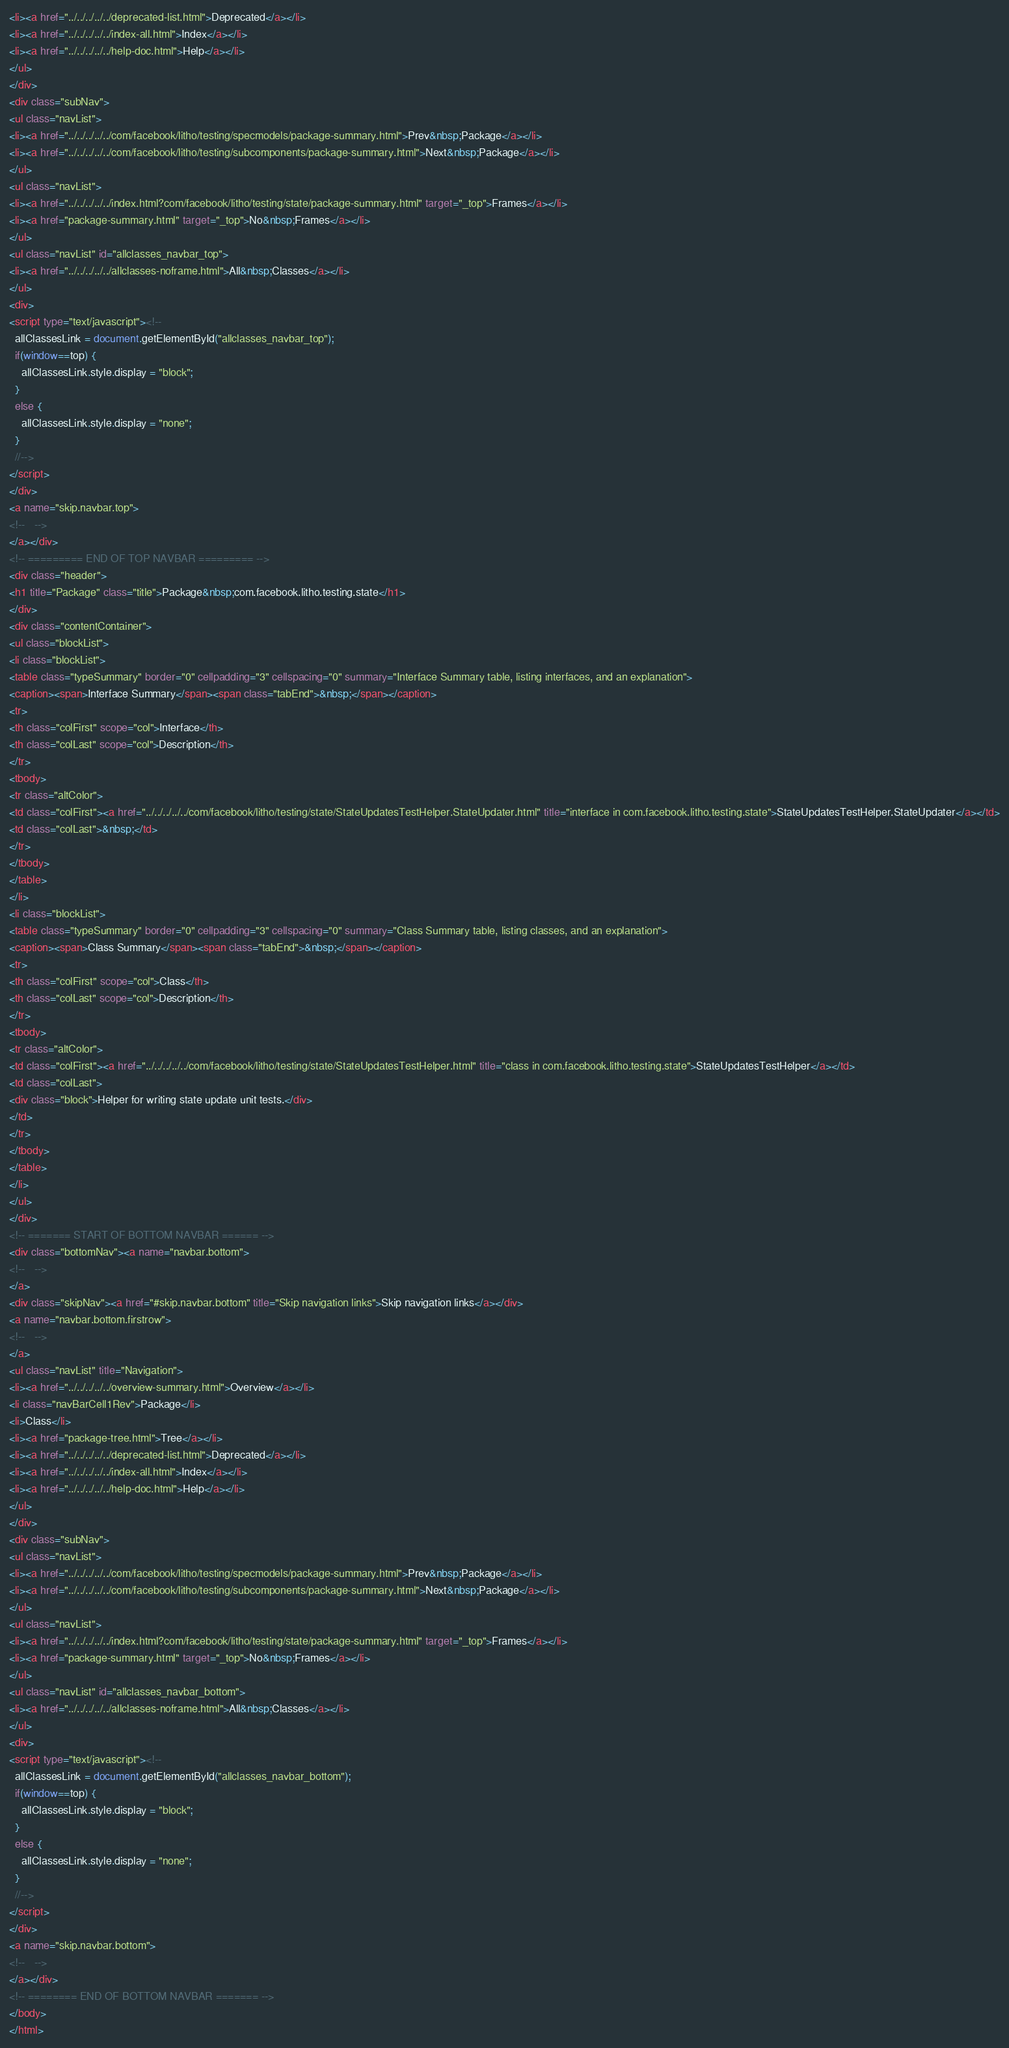Convert code to text. <code><loc_0><loc_0><loc_500><loc_500><_HTML_><li><a href="../../../../../deprecated-list.html">Deprecated</a></li>
<li><a href="../../../../../index-all.html">Index</a></li>
<li><a href="../../../../../help-doc.html">Help</a></li>
</ul>
</div>
<div class="subNav">
<ul class="navList">
<li><a href="../../../../../com/facebook/litho/testing/specmodels/package-summary.html">Prev&nbsp;Package</a></li>
<li><a href="../../../../../com/facebook/litho/testing/subcomponents/package-summary.html">Next&nbsp;Package</a></li>
</ul>
<ul class="navList">
<li><a href="../../../../../index.html?com/facebook/litho/testing/state/package-summary.html" target="_top">Frames</a></li>
<li><a href="package-summary.html" target="_top">No&nbsp;Frames</a></li>
</ul>
<ul class="navList" id="allclasses_navbar_top">
<li><a href="../../../../../allclasses-noframe.html">All&nbsp;Classes</a></li>
</ul>
<div>
<script type="text/javascript"><!--
  allClassesLink = document.getElementById("allclasses_navbar_top");
  if(window==top) {
    allClassesLink.style.display = "block";
  }
  else {
    allClassesLink.style.display = "none";
  }
  //-->
</script>
</div>
<a name="skip.navbar.top">
<!--   -->
</a></div>
<!-- ========= END OF TOP NAVBAR ========= -->
<div class="header">
<h1 title="Package" class="title">Package&nbsp;com.facebook.litho.testing.state</h1>
</div>
<div class="contentContainer">
<ul class="blockList">
<li class="blockList">
<table class="typeSummary" border="0" cellpadding="3" cellspacing="0" summary="Interface Summary table, listing interfaces, and an explanation">
<caption><span>Interface Summary</span><span class="tabEnd">&nbsp;</span></caption>
<tr>
<th class="colFirst" scope="col">Interface</th>
<th class="colLast" scope="col">Description</th>
</tr>
<tbody>
<tr class="altColor">
<td class="colFirst"><a href="../../../../../com/facebook/litho/testing/state/StateUpdatesTestHelper.StateUpdater.html" title="interface in com.facebook.litho.testing.state">StateUpdatesTestHelper.StateUpdater</a></td>
<td class="colLast">&nbsp;</td>
</tr>
</tbody>
</table>
</li>
<li class="blockList">
<table class="typeSummary" border="0" cellpadding="3" cellspacing="0" summary="Class Summary table, listing classes, and an explanation">
<caption><span>Class Summary</span><span class="tabEnd">&nbsp;</span></caption>
<tr>
<th class="colFirst" scope="col">Class</th>
<th class="colLast" scope="col">Description</th>
</tr>
<tbody>
<tr class="altColor">
<td class="colFirst"><a href="../../../../../com/facebook/litho/testing/state/StateUpdatesTestHelper.html" title="class in com.facebook.litho.testing.state">StateUpdatesTestHelper</a></td>
<td class="colLast">
<div class="block">Helper for writing state update unit tests.</div>
</td>
</tr>
</tbody>
</table>
</li>
</ul>
</div>
<!-- ======= START OF BOTTOM NAVBAR ====== -->
<div class="bottomNav"><a name="navbar.bottom">
<!--   -->
</a>
<div class="skipNav"><a href="#skip.navbar.bottom" title="Skip navigation links">Skip navigation links</a></div>
<a name="navbar.bottom.firstrow">
<!--   -->
</a>
<ul class="navList" title="Navigation">
<li><a href="../../../../../overview-summary.html">Overview</a></li>
<li class="navBarCell1Rev">Package</li>
<li>Class</li>
<li><a href="package-tree.html">Tree</a></li>
<li><a href="../../../../../deprecated-list.html">Deprecated</a></li>
<li><a href="../../../../../index-all.html">Index</a></li>
<li><a href="../../../../../help-doc.html">Help</a></li>
</ul>
</div>
<div class="subNav">
<ul class="navList">
<li><a href="../../../../../com/facebook/litho/testing/specmodels/package-summary.html">Prev&nbsp;Package</a></li>
<li><a href="../../../../../com/facebook/litho/testing/subcomponents/package-summary.html">Next&nbsp;Package</a></li>
</ul>
<ul class="navList">
<li><a href="../../../../../index.html?com/facebook/litho/testing/state/package-summary.html" target="_top">Frames</a></li>
<li><a href="package-summary.html" target="_top">No&nbsp;Frames</a></li>
</ul>
<ul class="navList" id="allclasses_navbar_bottom">
<li><a href="../../../../../allclasses-noframe.html">All&nbsp;Classes</a></li>
</ul>
<div>
<script type="text/javascript"><!--
  allClassesLink = document.getElementById("allclasses_navbar_bottom");
  if(window==top) {
    allClassesLink.style.display = "block";
  }
  else {
    allClassesLink.style.display = "none";
  }
  //-->
</script>
</div>
<a name="skip.navbar.bottom">
<!--   -->
</a></div>
<!-- ======== END OF BOTTOM NAVBAR ======= -->
</body>
</html>
</code> 